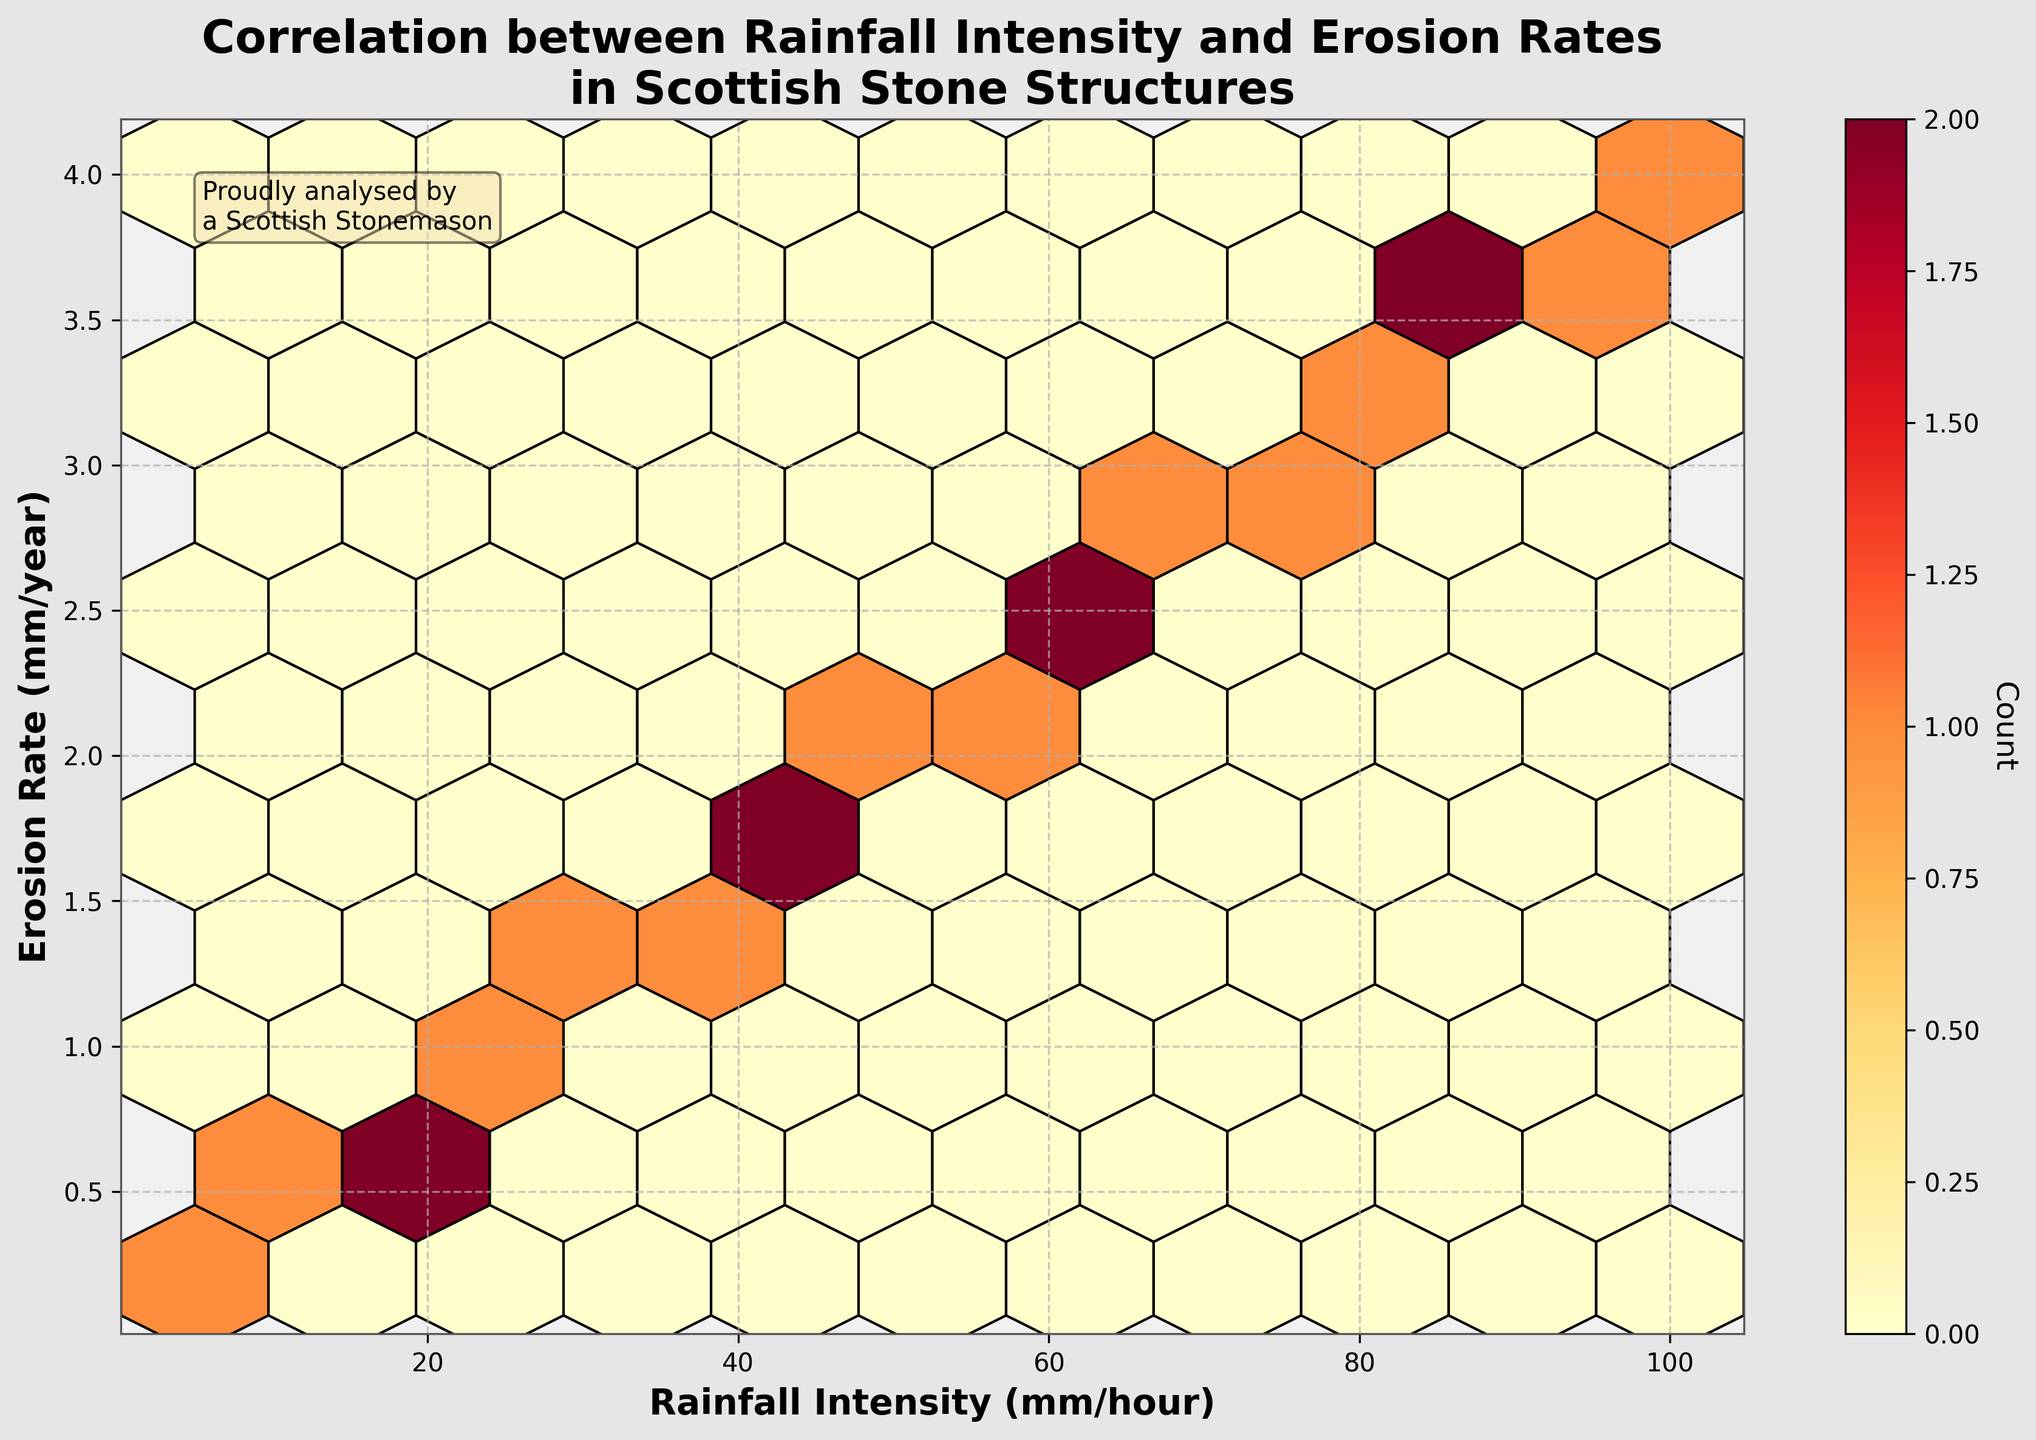What is the title of the hexbin plot? The plot's title can be read directly from the top of the figure. The title is given in large, bold font, clearly indicating the main subject of the plot.
Answer: Correlation between Rainfall Intensity and Erosion Rates in Scottish Stone Structures What does the color bar represent? The color bar is usually found adjacent to the plot and indicates the count of data points in each hexbin bin. The count is the number of data points falling within the spatial bounds of each hexbin.
Answer: Count What is the y-axis label? The y-axis label is found along the vertical axis of the plot. It is clearly marked in bold text to denote what is being measured on this axis.
Answer: Erosion Rate (mm/year) What is the x-axis label? The x-axis label is found along the horizontal axis of the plot. It is clearly marked in bold text to denote what is being measured on this axis.
Answer: Rainfall Intensity (mm/hour) What is the range of values for rainfall intensity presented in the plot? The x-axis provides a scale from the lowest to the highest value of rainfall intensity that is displayed on the plot. The two end points give the range.
Answer: 5 to 100 mm/hour What are the general trends between rainfall intensity and erosion rate? The hexbin plot represents relationships between the two variables graphically. The progression of data points diagonally from lower left to upper right suggests a correlation where increases in rainfall intensity are associated with increases in erosion rate.
Answer: Positive correlation Which location has the highest erosion rate depicted in the plot? The highest erosion rate can be identified by locating the topmost point on the y-axis. By referring to the data points within the highest hexbin, it can be determined which location corresponds to the highest y-value.
Answer: Brodie Castle How many data points would you estimate are in the densest hexbin? The color of the densest hexbin, as shown by the color bar, can be used to estimate the number of data points within it. The shade of the color indicates the count according to the color bar's legend.
Answer: Approximately 1 data point (referring to the color bar's lowest count value) What message does the text box on the plot convey? The plot has a text box that is placed near the top left corner inside the plot area. This text box contains information or a message from the analyst.
Answer: Proudly analysed by a Scottish Stonemason 